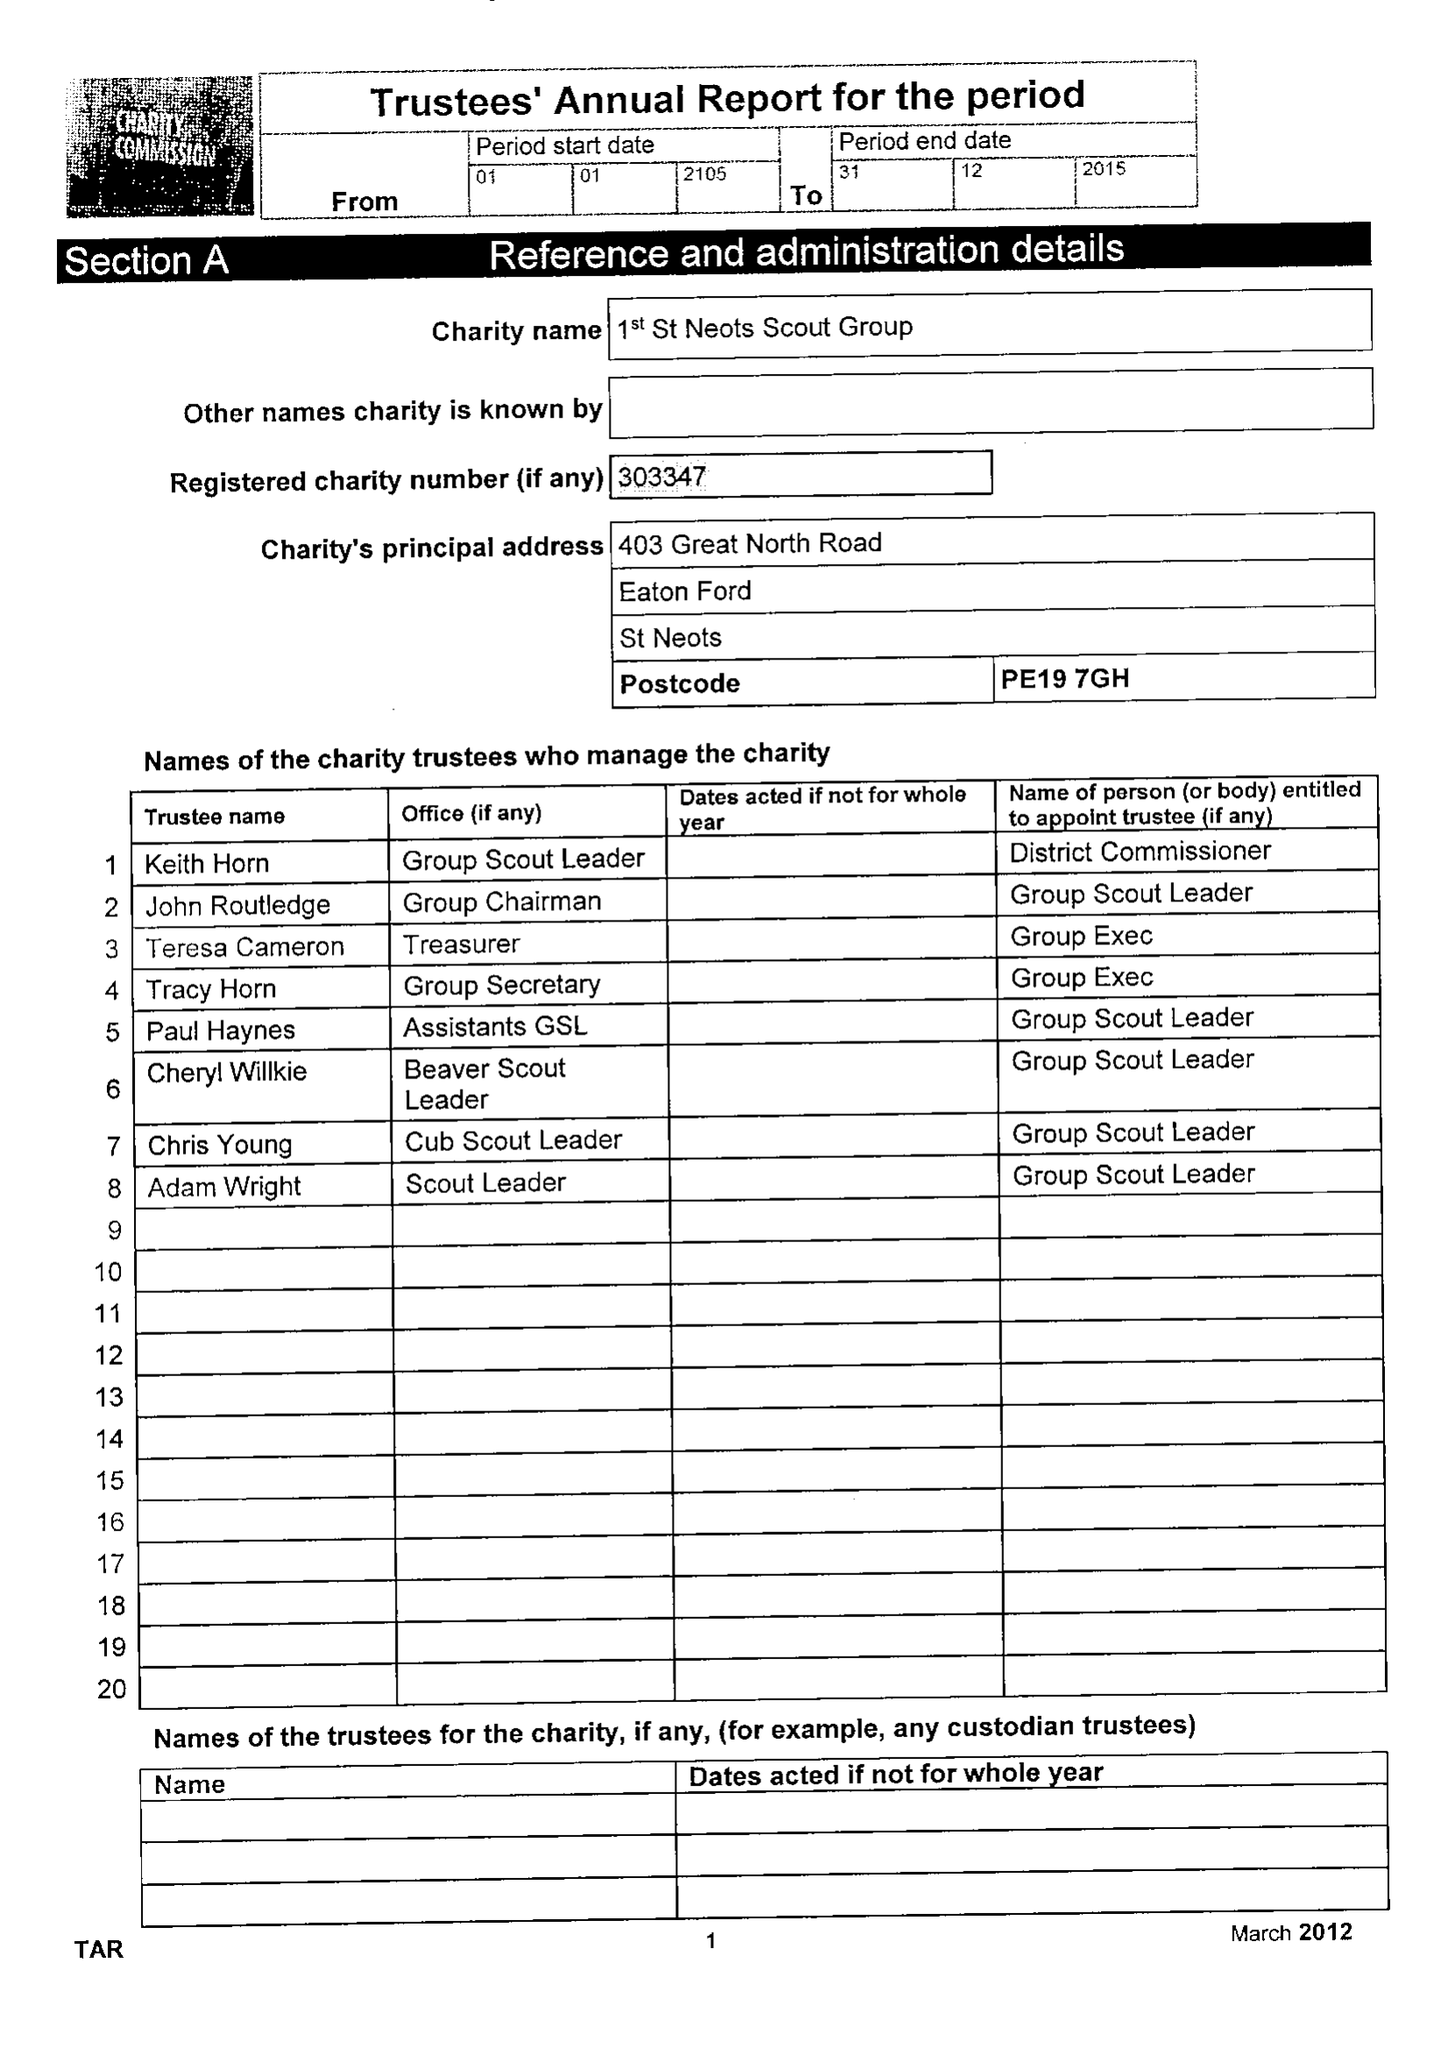What is the value for the charity_name?
Answer the question using a single word or phrase. 1st St Neots Scout Group 